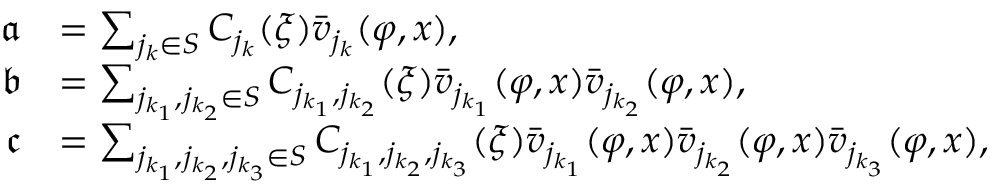<formula> <loc_0><loc_0><loc_500><loc_500>\begin{array} { r l } { \mathfrak { a } } & { = \sum _ { j _ { k } \in S } C _ { j _ { k } } ( \xi ) \bar { v } _ { j _ { k } } ( \varphi , x ) , } \\ { \mathfrak { b } } & { = \sum _ { j _ { k _ { 1 } } , j _ { k _ { 2 } } \in S } C _ { j _ { k _ { 1 } } , j _ { k _ { 2 } } } ( \xi ) \bar { v } _ { j _ { k _ { 1 } } } ( \varphi , x ) \bar { v } _ { j _ { k _ { 2 } } } ( \varphi , x ) , } \\ { \mathfrak { c } } & { = \sum _ { j _ { k _ { 1 } } , j _ { k _ { 2 } } , j _ { k _ { 3 } } \in S } C _ { j _ { k _ { 1 } } , j _ { k _ { 2 } } , j _ { k _ { 3 } } } ( \xi ) \bar { v } _ { j _ { k _ { 1 } } } ( \varphi , x ) \bar { v } _ { j _ { k _ { 2 } } } ( \varphi , x ) \bar { v } _ { j _ { k _ { 3 } } } ( \varphi , x ) , } \end{array}</formula> 